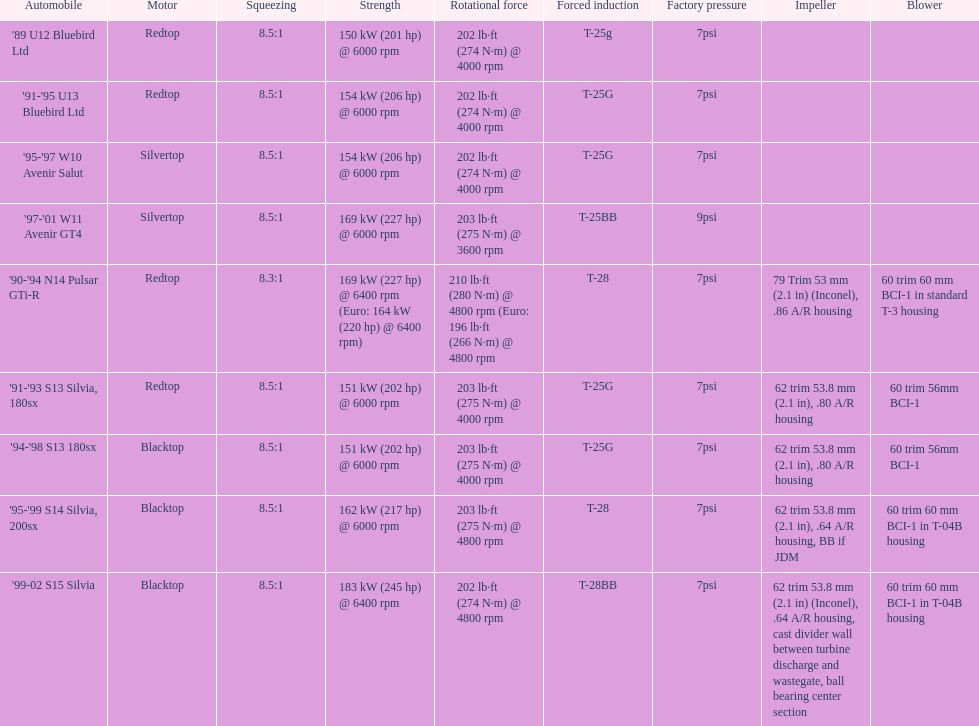Which car possesses an original boost exceeding 7psi? '97-'01 W11 Avenir GT4. 